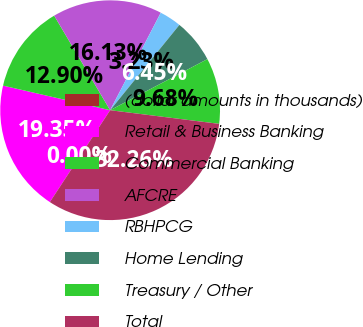<chart> <loc_0><loc_0><loc_500><loc_500><pie_chart><fcel>(dollar amounts in thousands)<fcel>Retail & Business Banking<fcel>Commercial Banking<fcel>AFCRE<fcel>RBHPCG<fcel>Home Lending<fcel>Treasury / Other<fcel>Total<nl><fcel>0.0%<fcel>19.35%<fcel>12.9%<fcel>16.13%<fcel>3.23%<fcel>6.45%<fcel>9.68%<fcel>32.26%<nl></chart> 